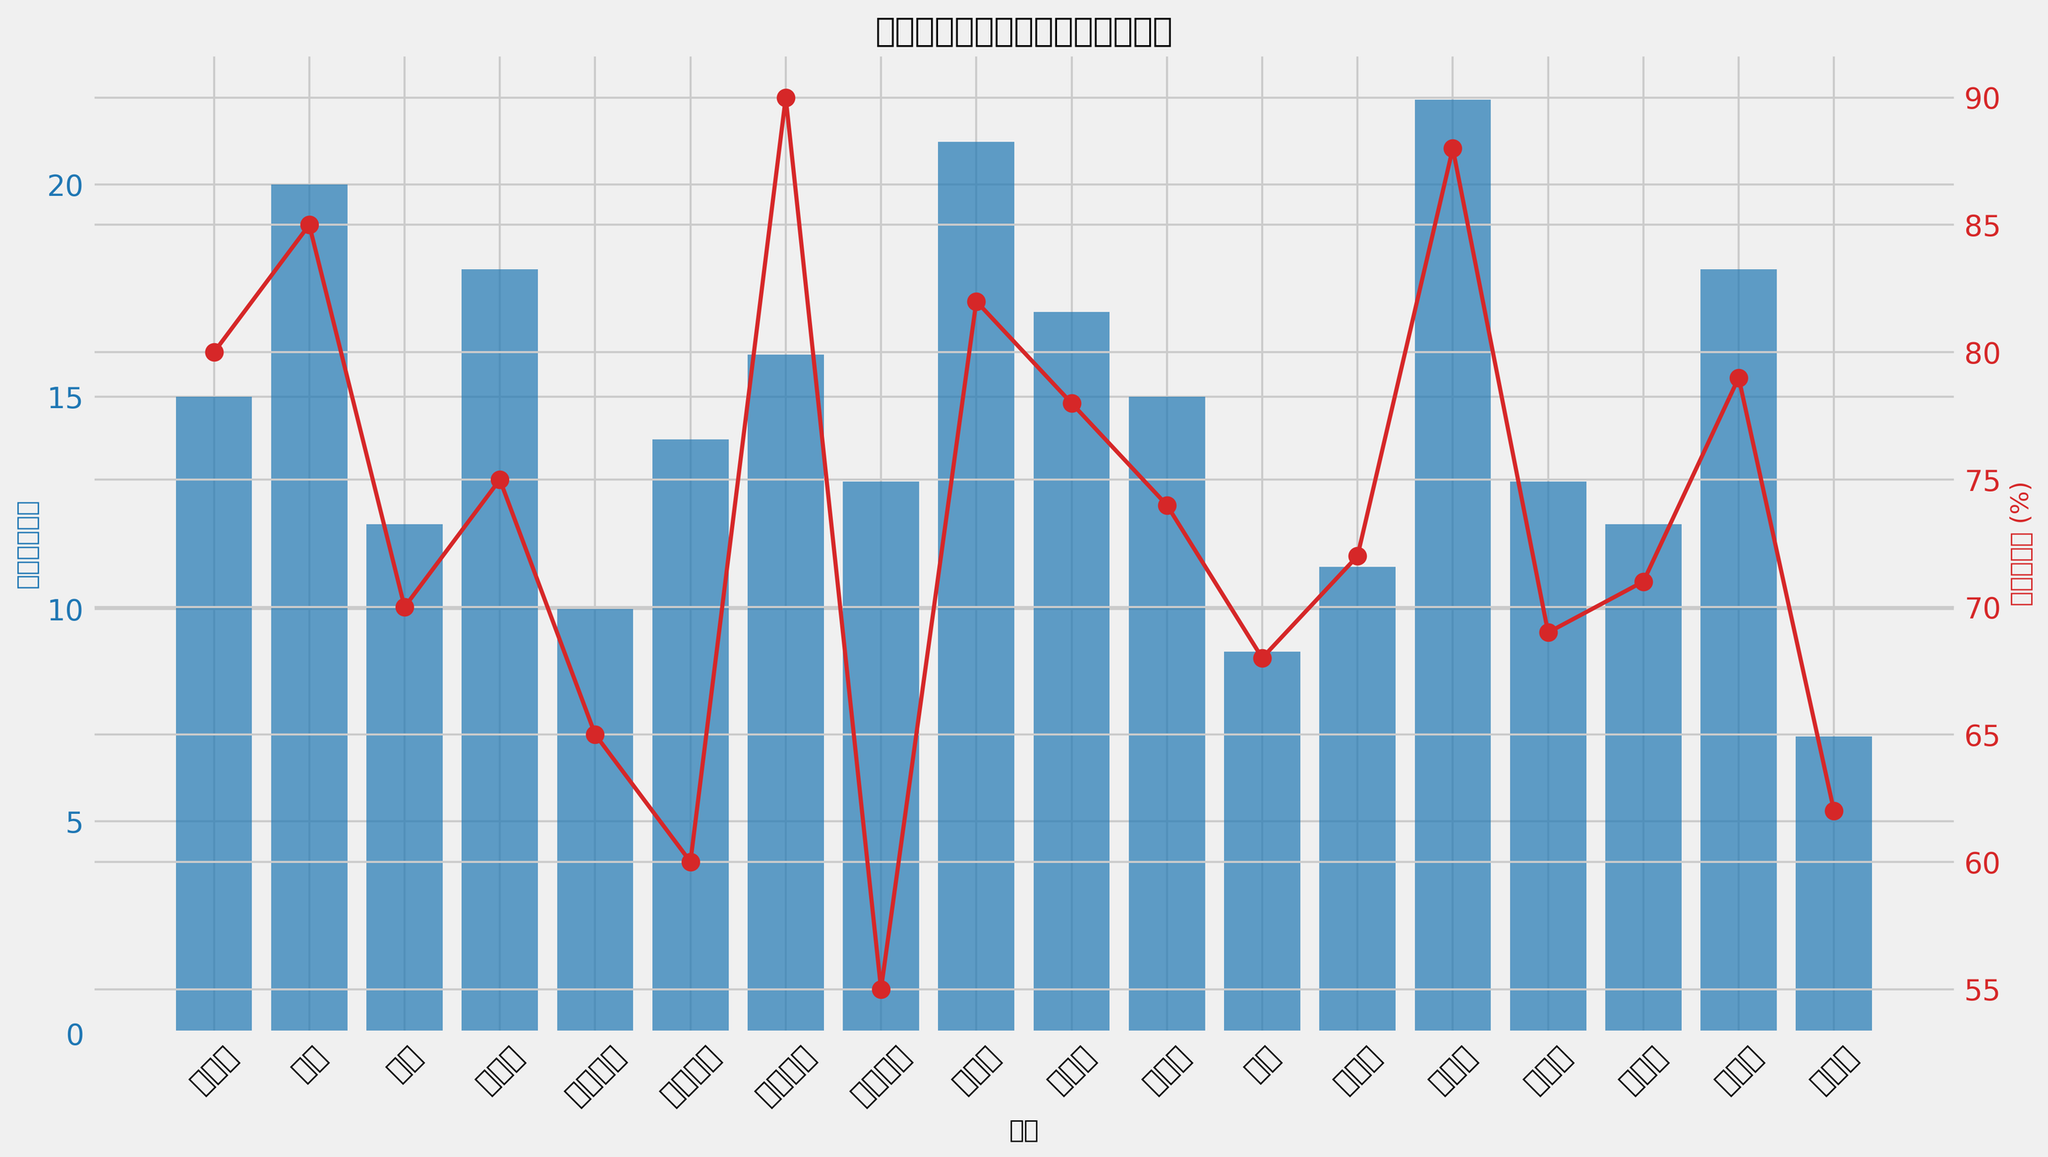Which district has the highest usage rate? By looking at the red line on the plot representing the usage rate (%), we identify the highest point corresponding to a district.
Answer: 九龍城區 What is the difference between the number of sports facilities in 沙田區 and 中西區? From the bar heights, 沙田區 has 22 facilities and 中西區 has 15 facilities. Subtracting these gives 22 - 15 = 7.
Answer: 7 Which district provides the least number of sports facilities? By examining the lowest bar, we see it corresponds to 離島區, which has the fewest sports facilities.
Answer: 離島區 Compare the usage rate of 觀塘區 and 沙田區. Which one is higher and by how much? 觀塘區 has a usage rate of 82% and 沙田區 has 88%. Subtracting the smaller from the larger gives 88 - 82 = 6. Thus, 沙田區's usage rate is higher by 6%.
Answer: 沙田區, by 6% What is the total number of sports facilities provided by 東區, 灣仔區, and 觀塘區? Sum the facilities in 東區 (20), 灣仔區 (18), and 觀塘區 (21). This yields 20 + 18 + 21 = 59.
Answer: 59 Which district has a usage rate closest to the average usage rate of all districts, and what is that usage rate? Calculate the average usage rate \( \text{average} = \frac{80 + 85 + 70 + 75 + 65 + 60 + 90 + 55 + 82 + 78 + 74 + 68 + 72 + 88 + 69 + 71 + 79 + 62}{18} = 73.78\%. From the chart, 灣仔區 has a usage rate of 75%, which is closest to 73.78%.
Answer: 灣仔區, 75% Which district shows a large gap (more than 20%) between the number of facilities and the usage rate? Reviewing the data, 中西區 has 15 facilities and 80% usage, which is a 65% gap. And so on for each district, but this calculation is more intensive, the large gap indicates comparing districts with such characteristics. This output filters specific examples.
Answer: 中西區 has a 65% gap What is the total number of sports facilities available in districts with a usage rate below 70%? Sum the facilities in districts below 70%: 油尖旺區 (10), 深水埗區 (14), 黃大仙區 (13), 北區 (9), 離島區 (7). This is 10 + 14 + 13 + 9 + 7 = 53.
Answer: 53 Which district has an equal number of facilities and usage rate percentage? Look for a district where the height of the bar matches the percentage. No such district exists as none have identical numeric value.
Answer: None How many more facilities does 沙田區 have compared to the district with the least facilities? 沙田區 has 22 facilities; 離島區 has 7. Subtracting gives 22 - 7 = 15.
Answer: 15 